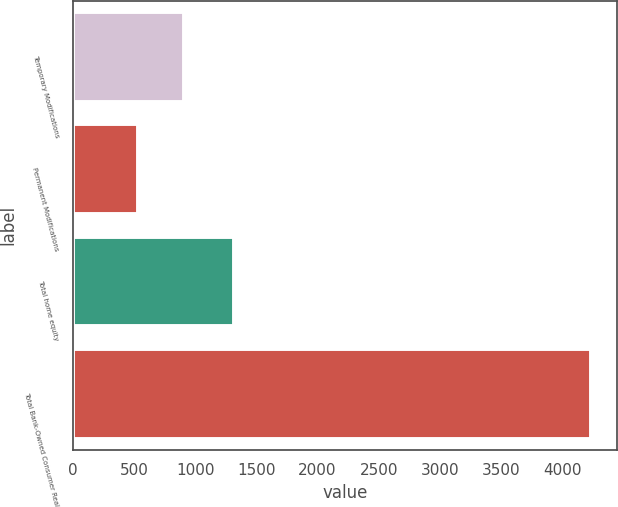<chart> <loc_0><loc_0><loc_500><loc_500><bar_chart><fcel>Temporary Modifications<fcel>Permanent Modifications<fcel>Total home equity<fcel>Total Bank-Owned Consumer Real<nl><fcel>904.9<fcel>535<fcel>1320<fcel>4234<nl></chart> 